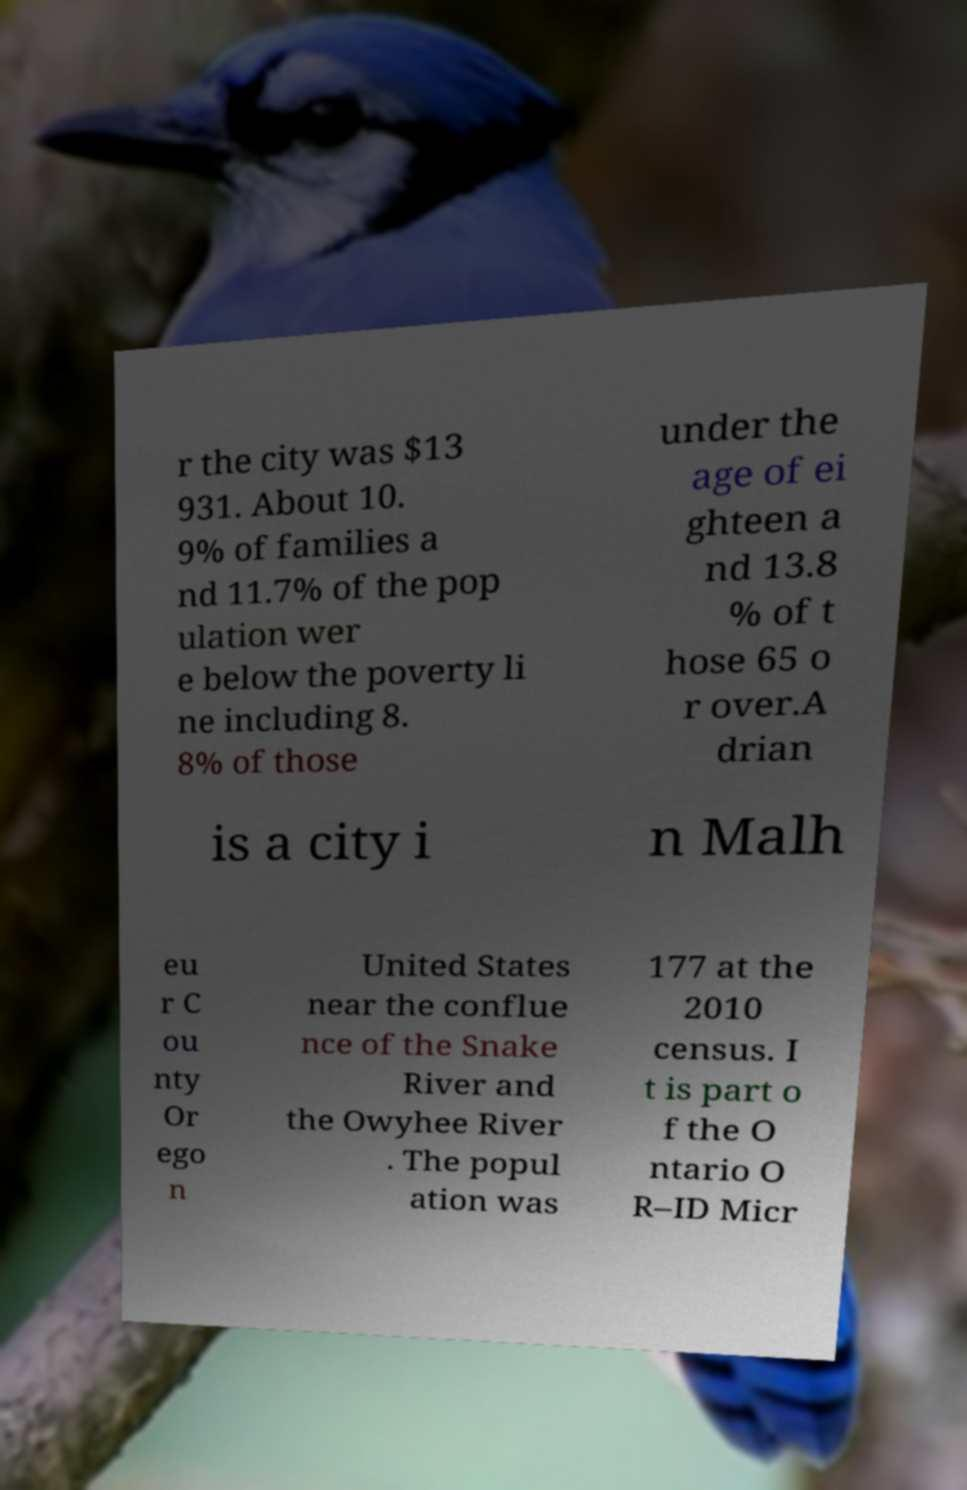What messages or text are displayed in this image? I need them in a readable, typed format. r the city was $13 931. About 10. 9% of families a nd 11.7% of the pop ulation wer e below the poverty li ne including 8. 8% of those under the age of ei ghteen a nd 13.8 % of t hose 65 o r over.A drian is a city i n Malh eu r C ou nty Or ego n United States near the conflue nce of the Snake River and the Owyhee River . The popul ation was 177 at the 2010 census. I t is part o f the O ntario O R–ID Micr 